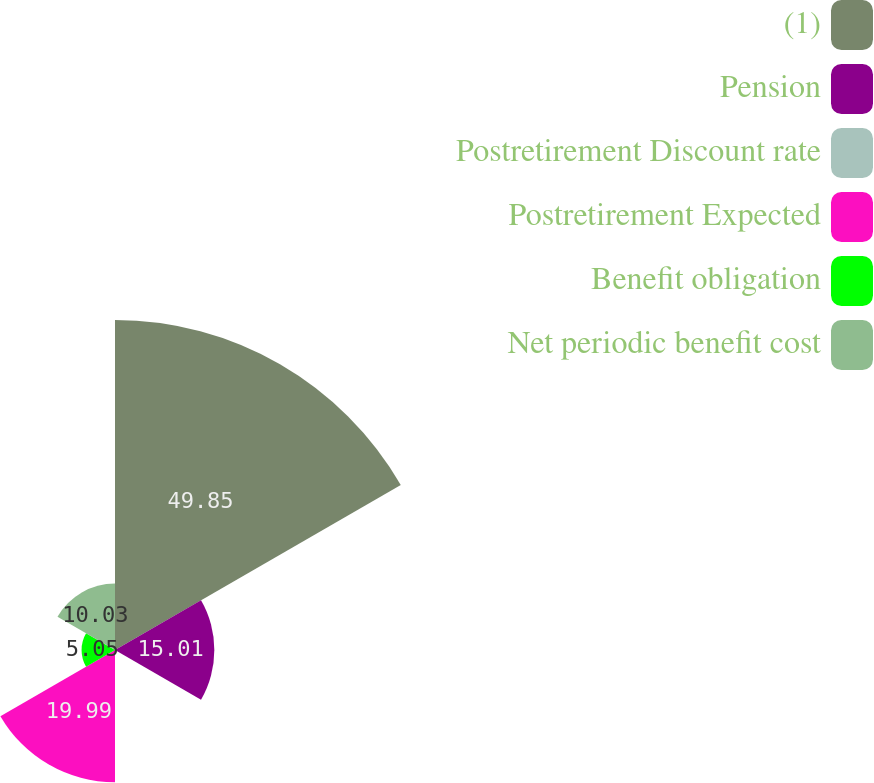Convert chart. <chart><loc_0><loc_0><loc_500><loc_500><pie_chart><fcel>(1)<fcel>Pension<fcel>Postretirement Discount rate<fcel>Postretirement Expected<fcel>Benefit obligation<fcel>Net periodic benefit cost<nl><fcel>49.86%<fcel>15.01%<fcel>0.07%<fcel>19.99%<fcel>5.05%<fcel>10.03%<nl></chart> 